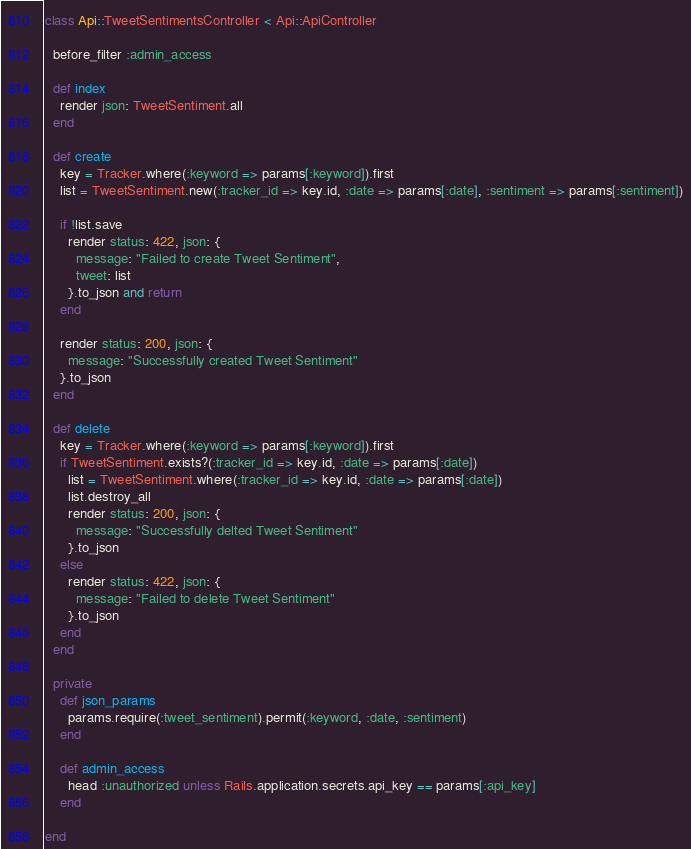<code> <loc_0><loc_0><loc_500><loc_500><_Ruby_>class Api::TweetSentimentsController < Api::ApiController

  before_filter :admin_access

  def index
    render json: TweetSentiment.all
  end

  def create
    key = Tracker.where(:keyword => params[:keyword]).first
    list = TweetSentiment.new(:tracker_id => key.id, :date => params[:date], :sentiment => params[:sentiment])

    if !list.save
      render status: 422, json: {
        message: "Failed to create Tweet Sentiment",
        tweet: list
      }.to_json and return
    end

    render status: 200, json: {
      message: "Successfully created Tweet Sentiment"
    }.to_json
  end

  def delete
    key = Tracker.where(:keyword => params[:keyword]).first
    if TweetSentiment.exists?(:tracker_id => key.id, :date => params[:date])
      list = TweetSentiment.where(:tracker_id => key.id, :date => params[:date])
      list.destroy_all
      render status: 200, json: {
        message: "Successfully delted Tweet Sentiment"
      }.to_json
    else
      render status: 422, json: {
        message: "Failed to delete Tweet Sentiment"
      }.to_json
    end
  end

  private
    def json_params
      params.require(:tweet_sentiment).permit(:keyword, :date, :sentiment)
    end

    def admin_access
      head :unauthorized unless Rails.application.secrets.api_key == params[:api_key]
    end

end
</code> 